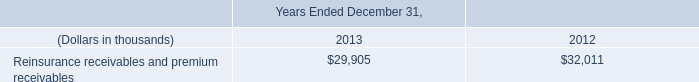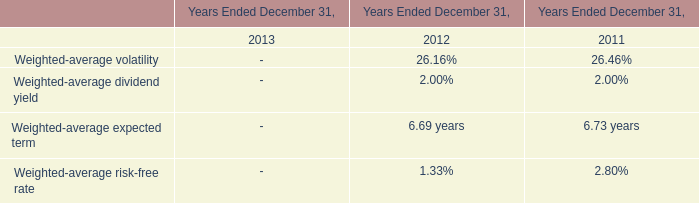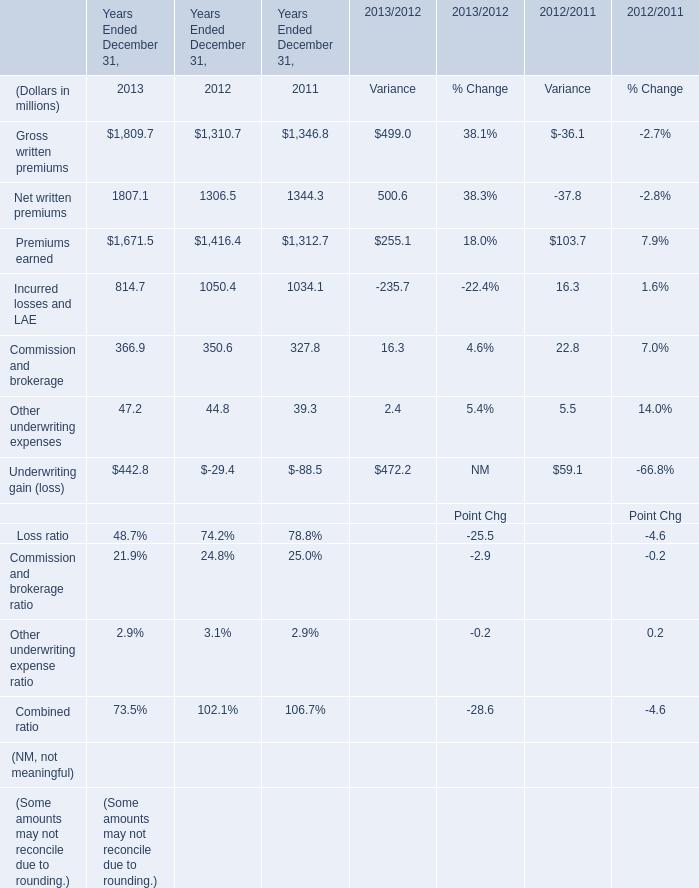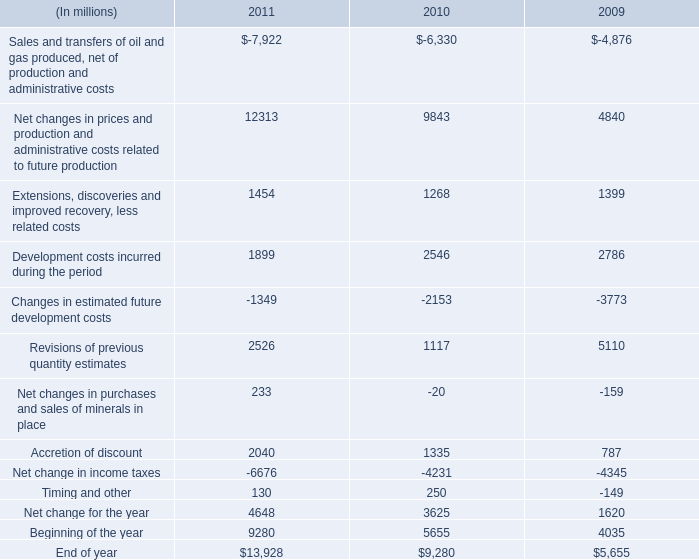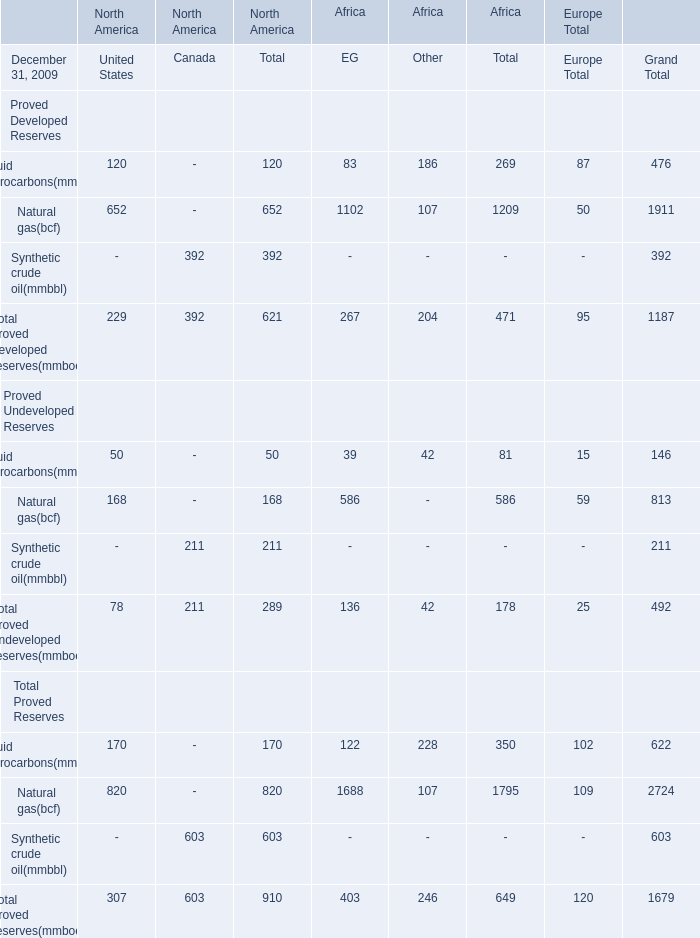In the year with largest amount of Gross written premiums, what's the sum of Premiums earned and Incurred losses and LAE ? (in million) 
Computations: (1671.5 + 814.7)
Answer: 2486.2. 